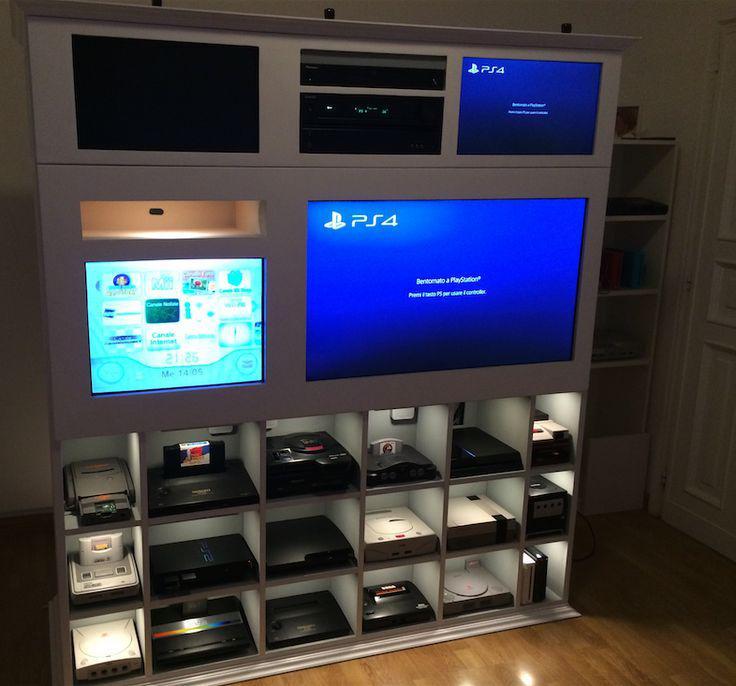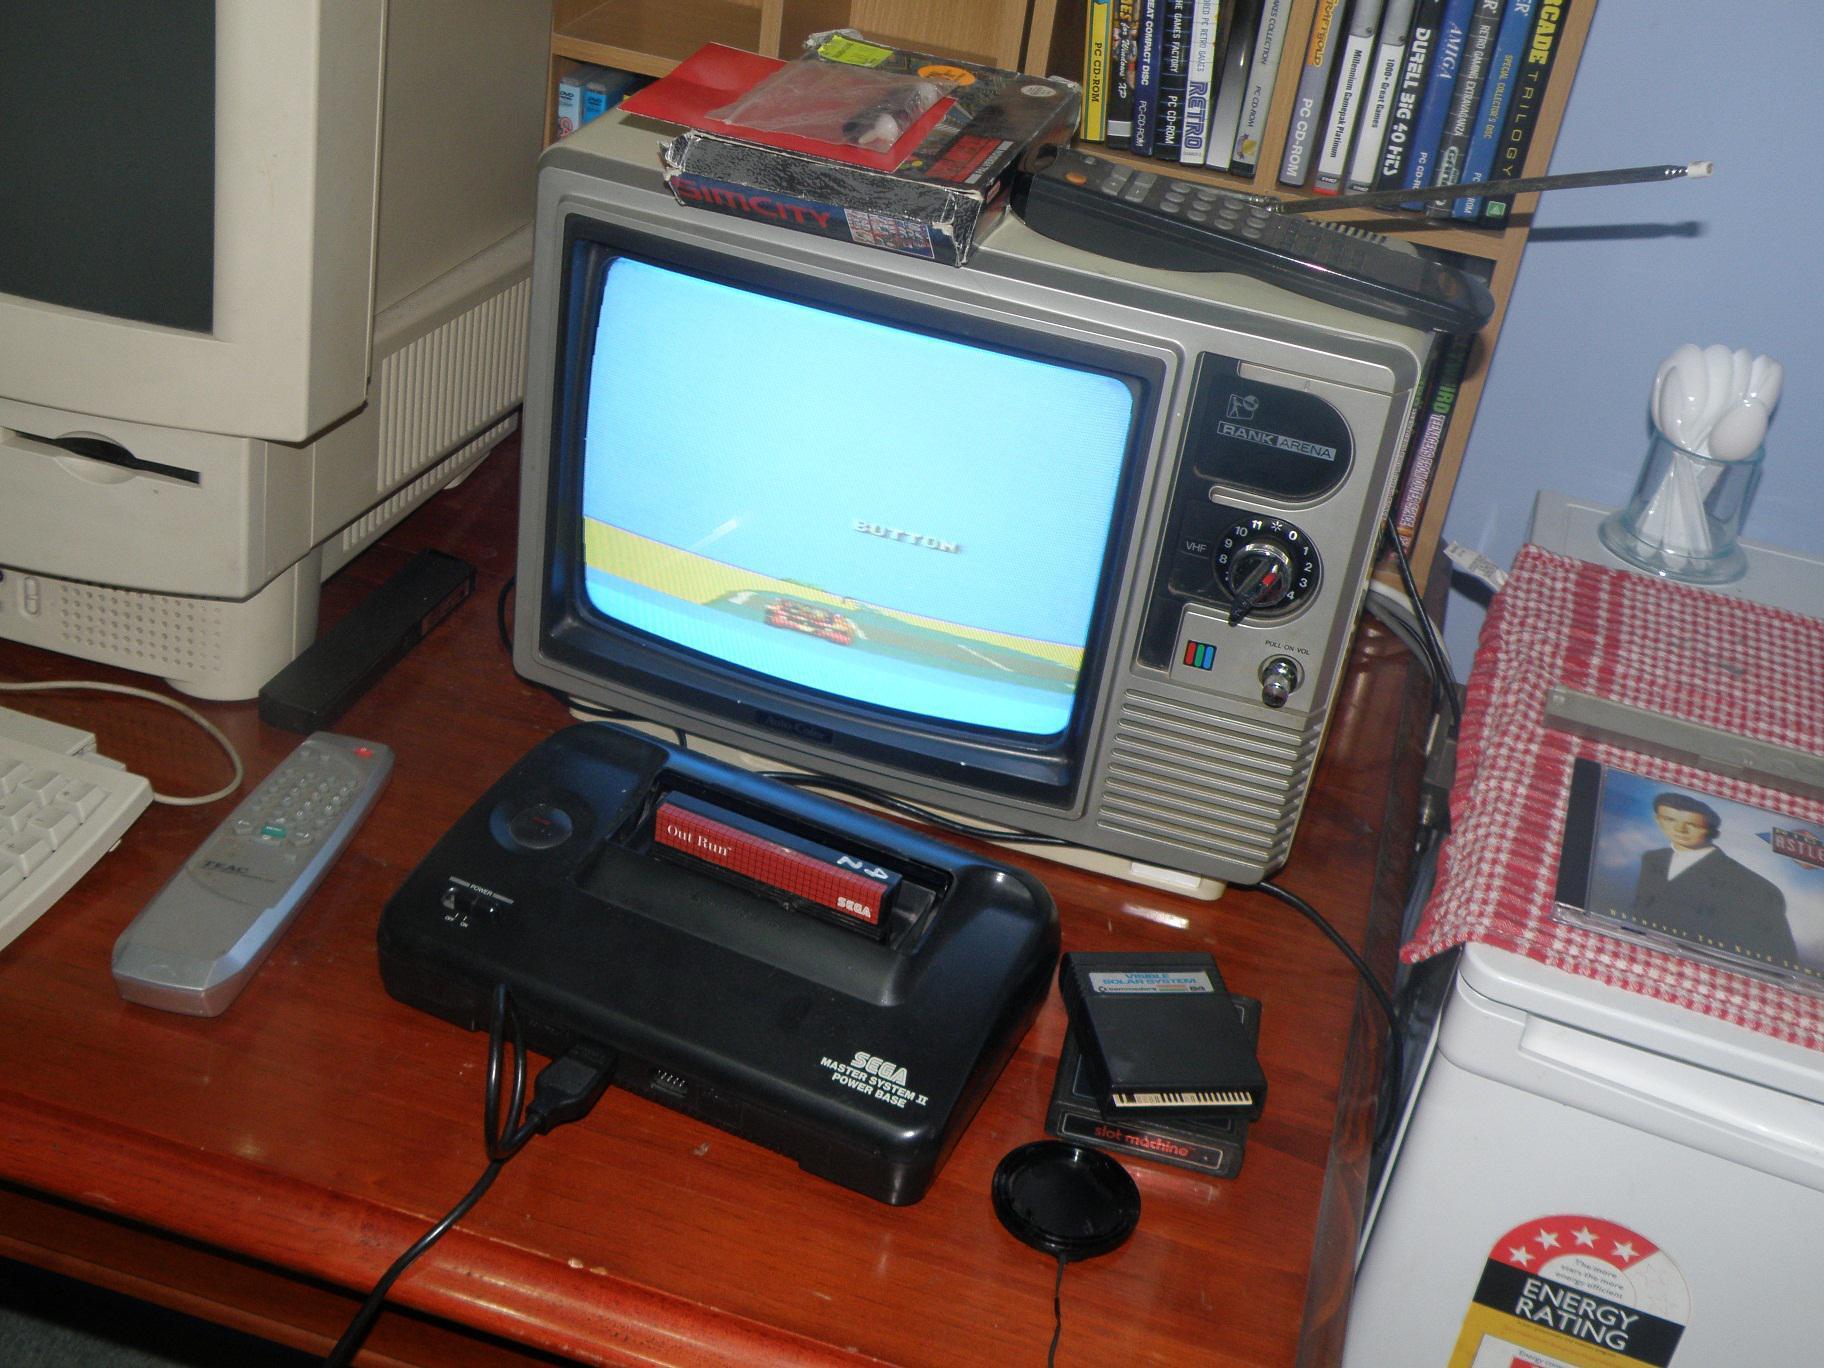The first image is the image on the left, the second image is the image on the right. Assess this claim about the two images: "The right image contains  television with an antenna.". Correct or not? Answer yes or no. Yes. 